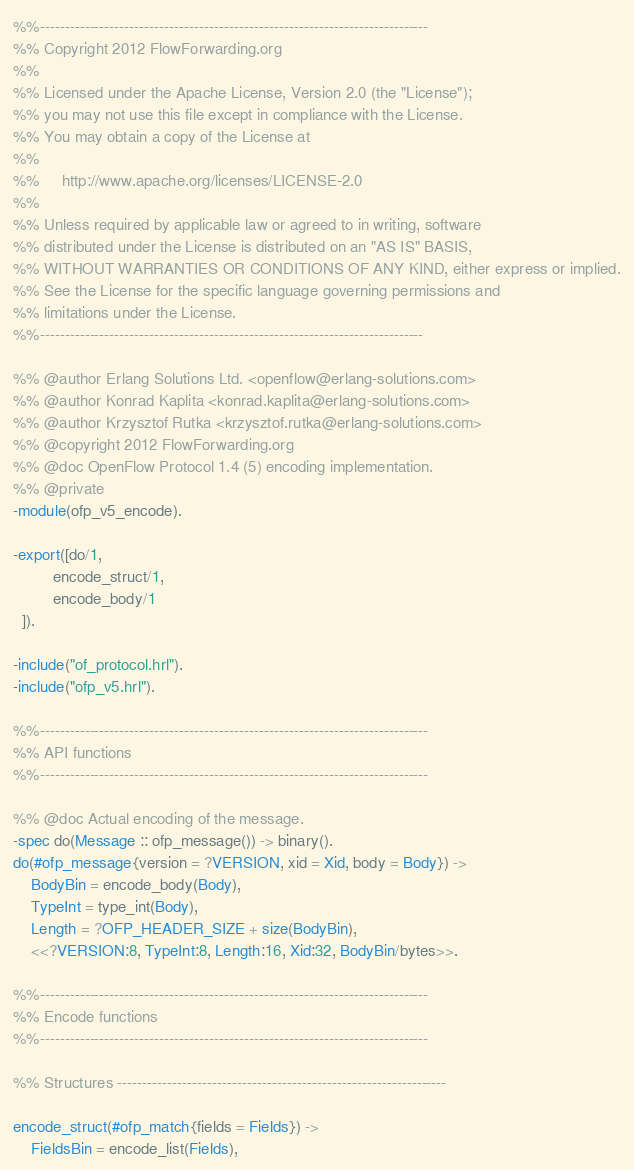<code> <loc_0><loc_0><loc_500><loc_500><_Erlang_>%%------------------------------------------------------------------------------
%% Copyright 2012 FlowForwarding.org
%%
%% Licensed under the Apache License, Version 2.0 (the "License");
%% you may not use this file except in compliance with the License.
%% You may obtain a copy of the License at
%%
%%     http://www.apache.org/licenses/LICENSE-2.0
%%
%% Unless required by applicable law or agreed to in writing, software
%% distributed under the License is distributed on an "AS IS" BASIS,
%% WITHOUT WARRANTIES OR CONDITIONS OF ANY KIND, either express or implied.
%% See the License for the specific language governing permissions and
%% limitations under the License.
%%-----------------------------------------------------------------------------

%% @author Erlang Solutions Ltd. <openflow@erlang-solutions.com>
%% @author Konrad Kaplita <konrad.kaplita@erlang-solutions.com>
%% @author Krzysztof Rutka <krzysztof.rutka@erlang-solutions.com>
%% @copyright 2012 FlowForwarding.org
%% @doc OpenFlow Protocol 1.4 (5) encoding implementation.
%% @private
-module(ofp_v5_encode).

-export([do/1,
         encode_struct/1,
         encode_body/1
  ]).

-include("of_protocol.hrl").
-include("ofp_v5.hrl").

%%------------------------------------------------------------------------------
%% API functions
%%------------------------------------------------------------------------------

%% @doc Actual encoding of the message.
-spec do(Message :: ofp_message()) -> binary().
do(#ofp_message{version = ?VERSION, xid = Xid, body = Body}) ->
    BodyBin = encode_body(Body),
    TypeInt = type_int(Body),
    Length = ?OFP_HEADER_SIZE + size(BodyBin),
    <<?VERSION:8, TypeInt:8, Length:16, Xid:32, BodyBin/bytes>>.

%%------------------------------------------------------------------------------
%% Encode functions
%%------------------------------------------------------------------------------

%% Structures ------------------------------------------------------------------

encode_struct(#ofp_match{fields = Fields}) ->
    FieldsBin = encode_list(Fields),</code> 